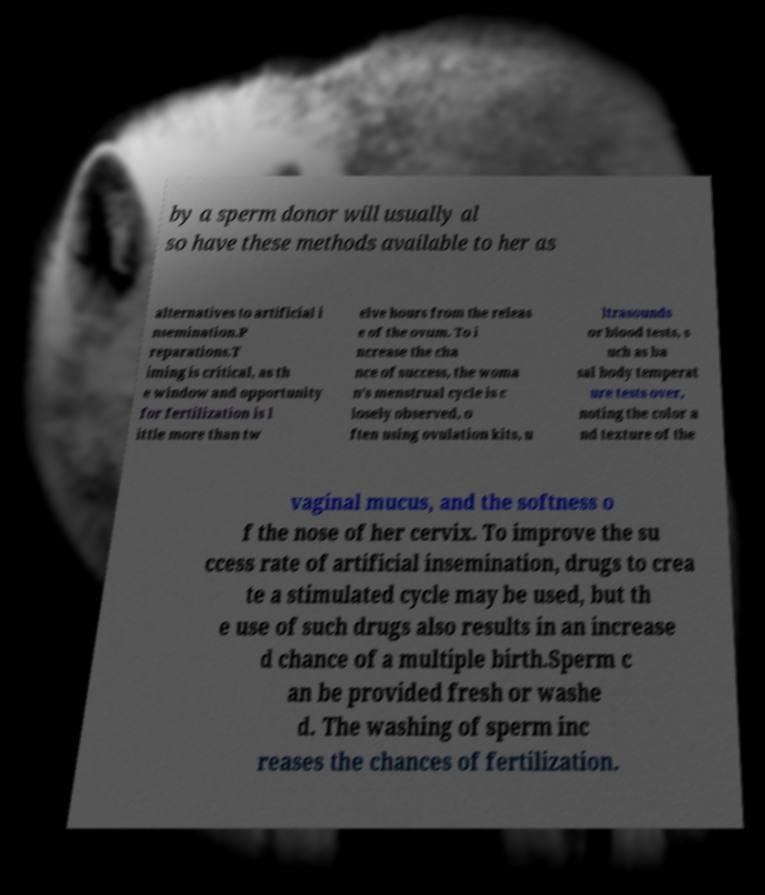Please identify and transcribe the text found in this image. by a sperm donor will usually al so have these methods available to her as alternatives to artificial i nsemination.P reparations.T iming is critical, as th e window and opportunity for fertilization is l ittle more than tw elve hours from the releas e of the ovum. To i ncrease the cha nce of success, the woma n's menstrual cycle is c losely observed, o ften using ovulation kits, u ltrasounds or blood tests, s uch as ba sal body temperat ure tests over, noting the color a nd texture of the vaginal mucus, and the softness o f the nose of her cervix. To improve the su ccess rate of artificial insemination, drugs to crea te a stimulated cycle may be used, but th e use of such drugs also results in an increase d chance of a multiple birth.Sperm c an be provided fresh or washe d. The washing of sperm inc reases the chances of fertilization. 